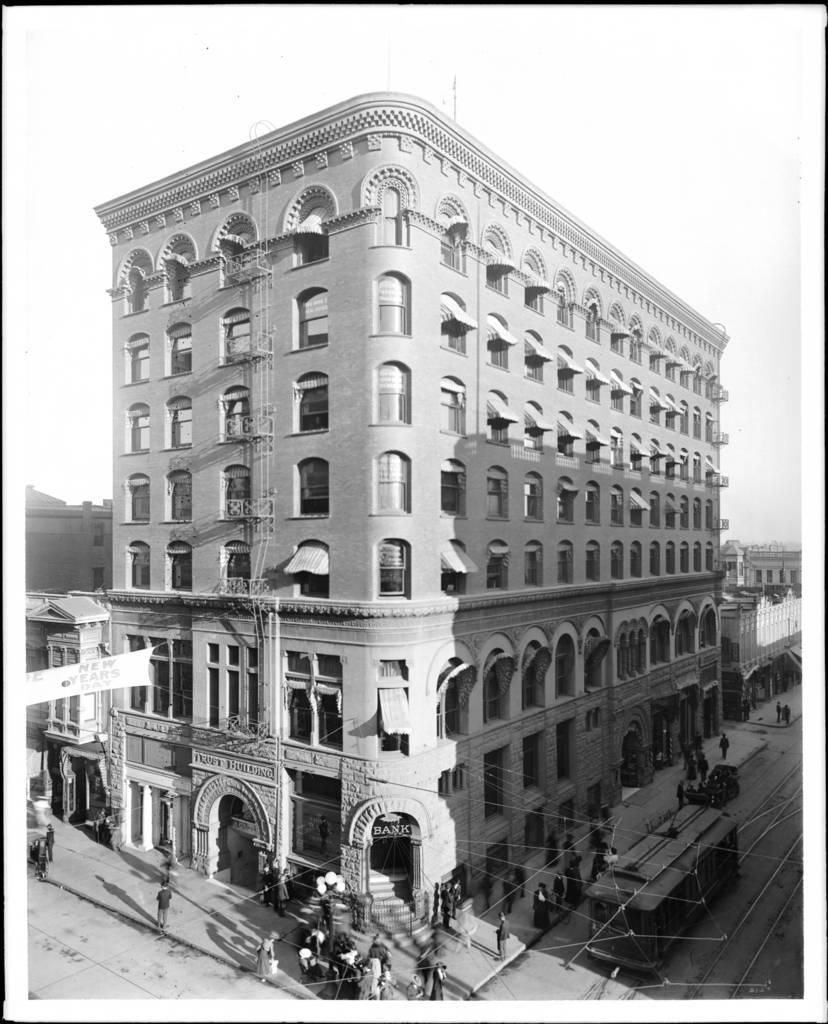Could you give a brief overview of what you see in this image? In this image in the center there are persons, vehicles. In the background there are buildings. 